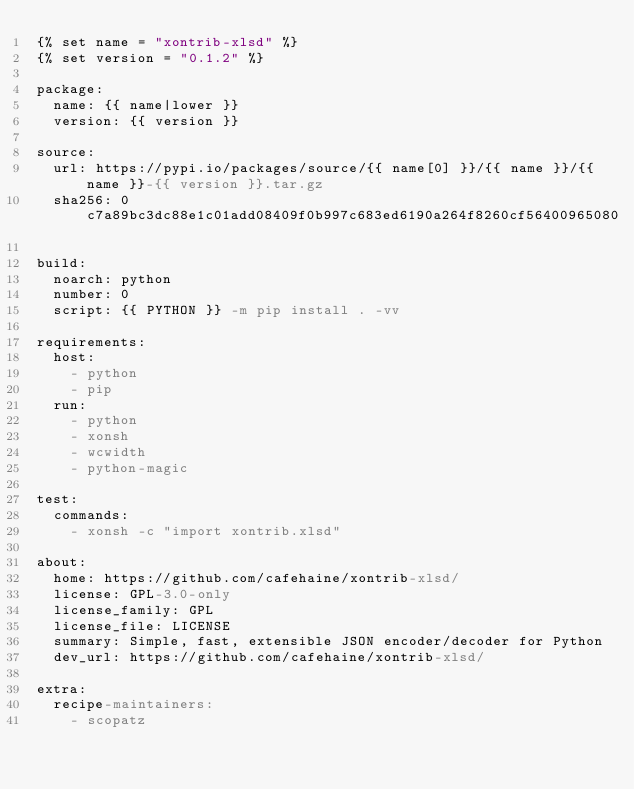<code> <loc_0><loc_0><loc_500><loc_500><_YAML_>{% set name = "xontrib-xlsd" %}
{% set version = "0.1.2" %}

package:
  name: {{ name|lower }}
  version: {{ version }}

source:
  url: https://pypi.io/packages/source/{{ name[0] }}/{{ name }}/{{ name }}-{{ version }}.tar.gz
  sha256: 0c7a89bc3dc88e1c01add08409f0b997c683ed6190a264f8260cf56400965080

build:
  noarch: python
  number: 0
  script: {{ PYTHON }} -m pip install . -vv

requirements:
  host:
    - python
    - pip
  run:
    - python
    - xonsh
    - wcwidth
    - python-magic

test:
  commands:
    - xonsh -c "import xontrib.xlsd"

about:
  home: https://github.com/cafehaine/xontrib-xlsd/
  license: GPL-3.0-only
  license_family: GPL
  license_file: LICENSE
  summary: Simple, fast, extensible JSON encoder/decoder for Python
  dev_url: https://github.com/cafehaine/xontrib-xlsd/

extra:
  recipe-maintainers:
    - scopatz
</code> 